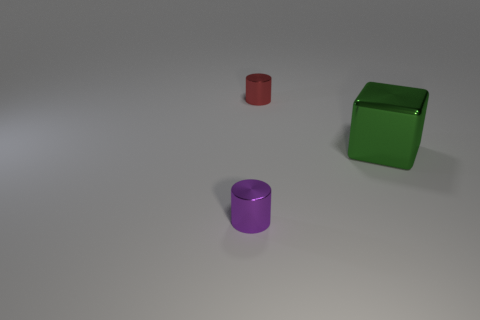Is the number of small purple objects that are behind the purple object the same as the number of tiny red things?
Make the answer very short. No. What number of objects are either metallic objects that are behind the purple thing or small metallic things?
Ensure brevity in your answer.  3. There is a tiny shiny object that is on the left side of the red object; is it the same color as the big shiny object?
Your answer should be compact. No. How big is the cylinder that is right of the purple metallic cylinder?
Keep it short and to the point. Small. There is a small thing in front of the small thing behind the purple cylinder; what is its shape?
Your answer should be compact. Cylinder. What color is the other tiny shiny thing that is the same shape as the tiny red shiny object?
Your answer should be very brief. Purple. There is a metallic cylinder that is in front of the metal block; does it have the same size as the green object?
Offer a terse response. No. What number of green objects have the same material as the tiny red object?
Keep it short and to the point. 1. There is a small object to the right of the metallic cylinder on the left side of the cylinder that is right of the tiny purple cylinder; what is it made of?
Give a very brief answer. Metal. There is a cylinder that is left of the tiny thing that is behind the big green metal object; what color is it?
Offer a terse response. Purple. 